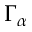Convert formula to latex. <formula><loc_0><loc_0><loc_500><loc_500>\Gamma _ { \alpha }</formula> 